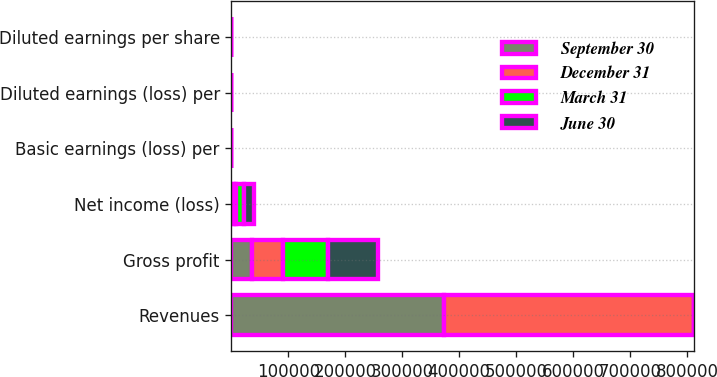Convert chart. <chart><loc_0><loc_0><loc_500><loc_500><stacked_bar_chart><ecel><fcel>Revenues<fcel>Gross profit<fcel>Net income (loss)<fcel>Basic earnings (loss) per<fcel>Diluted earnings (loss) per<fcel>Diluted earnings per share<nl><fcel>September 30<fcel>372505<fcel>36092<fcel>5128<fcel>0.04<fcel>0.04<fcel>0.07<nl><fcel>December 31<fcel>439287<fcel>53816<fcel>3343<fcel>0.03<fcel>0.03<fcel>0.14<nl><fcel>March 31<fcel>0.215<fcel>80173<fcel>12880<fcel>0.11<fcel>0.11<fcel>0.17<nl><fcel>June 30<fcel>0.215<fcel>86667<fcel>18462<fcel>0.16<fcel>0.15<fcel>0.26<nl></chart> 